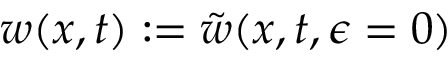Convert formula to latex. <formula><loc_0><loc_0><loc_500><loc_500>w ( x , t ) \colon = \tilde { w } ( x , t , \epsilon = 0 )</formula> 